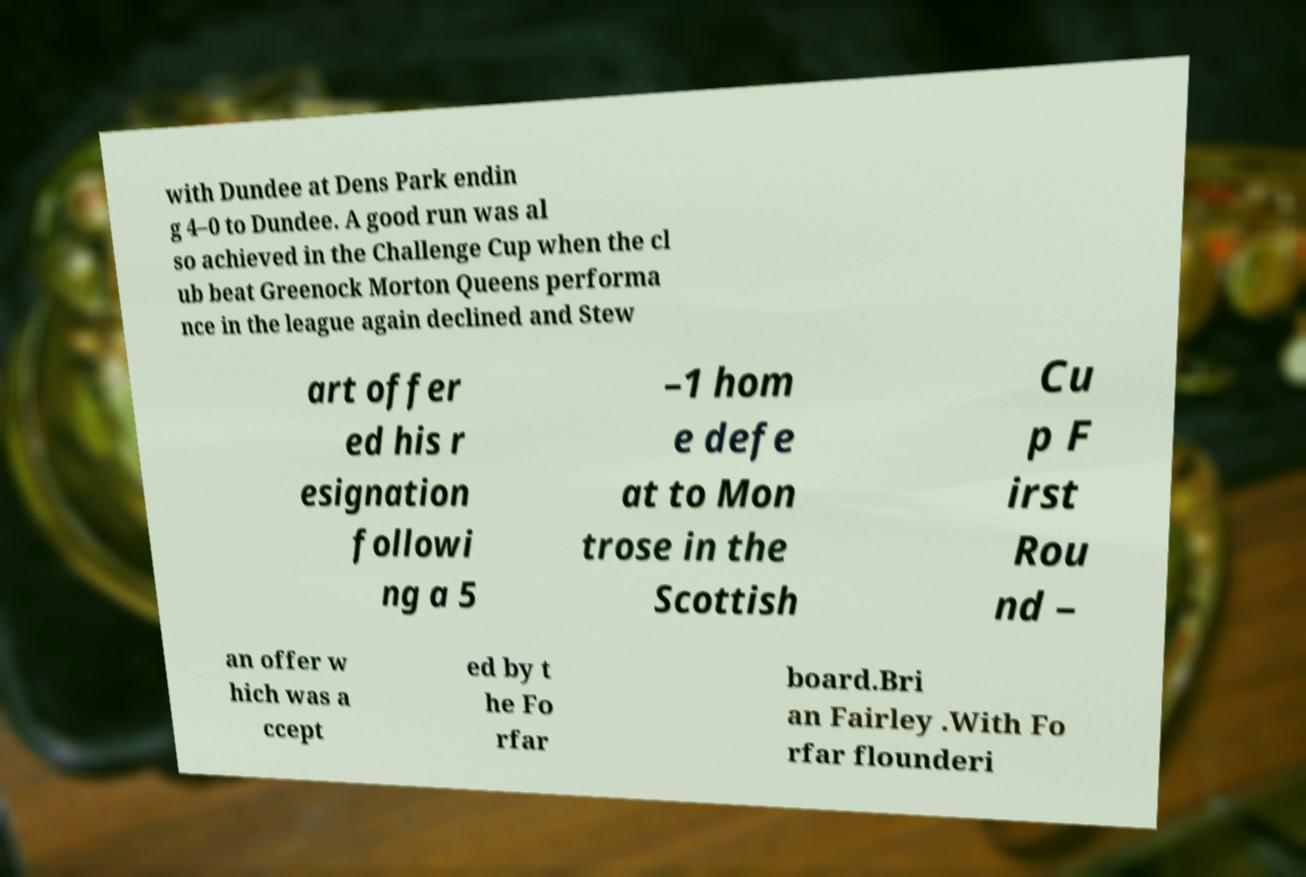Please identify and transcribe the text found in this image. with Dundee at Dens Park endin g 4–0 to Dundee. A good run was al so achieved in the Challenge Cup when the cl ub beat Greenock Morton Queens performa nce in the league again declined and Stew art offer ed his r esignation followi ng a 5 –1 hom e defe at to Mon trose in the Scottish Cu p F irst Rou nd – an offer w hich was a ccept ed by t he Fo rfar board.Bri an Fairley .With Fo rfar flounderi 